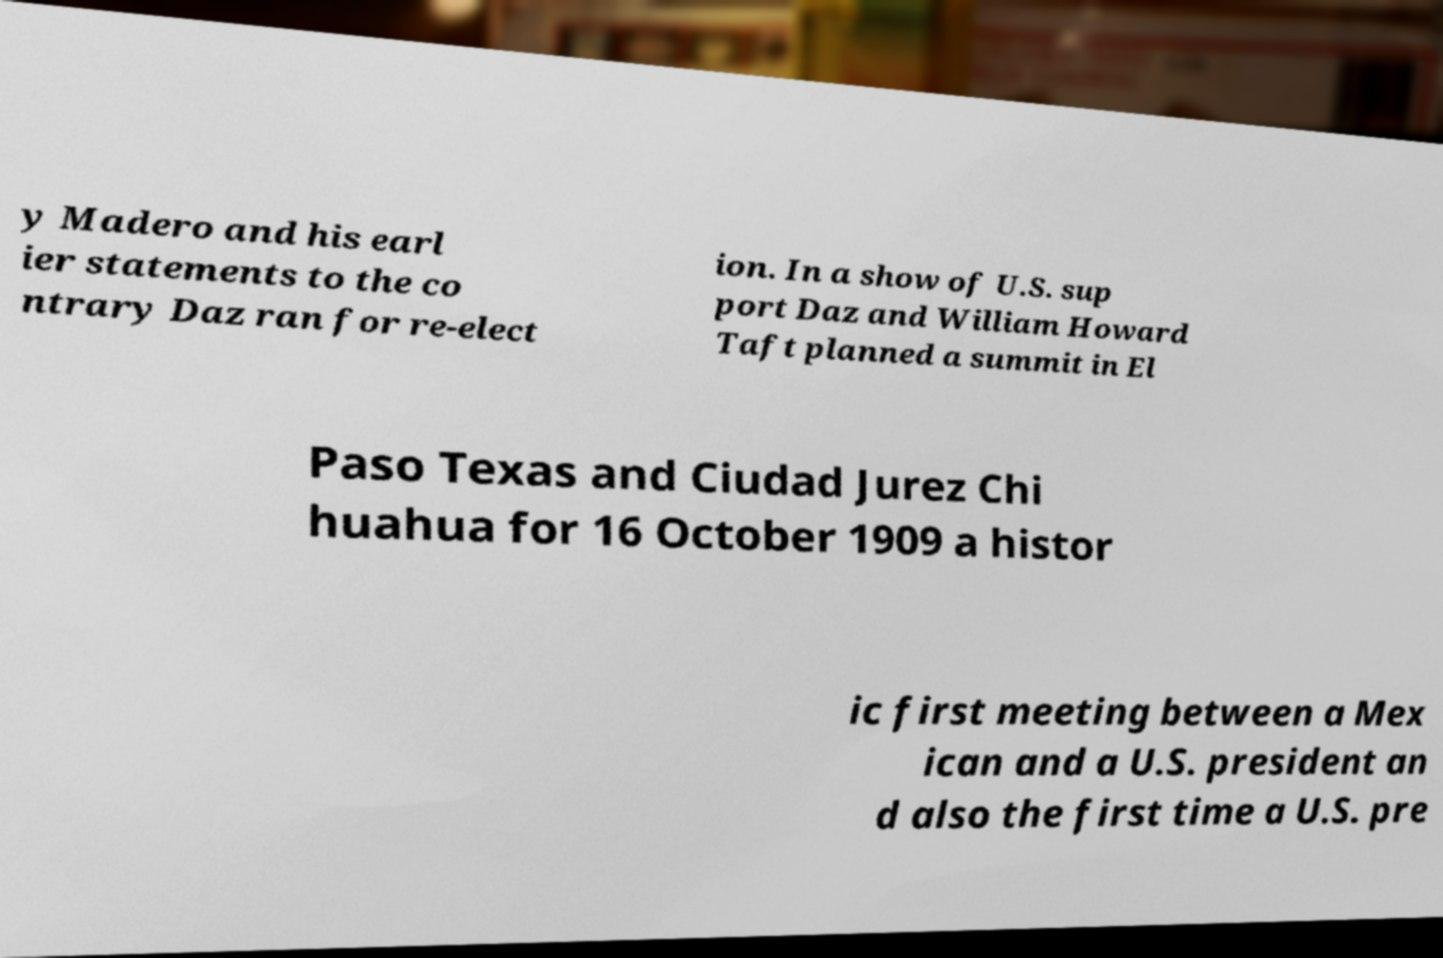Could you assist in decoding the text presented in this image and type it out clearly? y Madero and his earl ier statements to the co ntrary Daz ran for re-elect ion. In a show of U.S. sup port Daz and William Howard Taft planned a summit in El Paso Texas and Ciudad Jurez Chi huahua for 16 October 1909 a histor ic first meeting between a Mex ican and a U.S. president an d also the first time a U.S. pre 